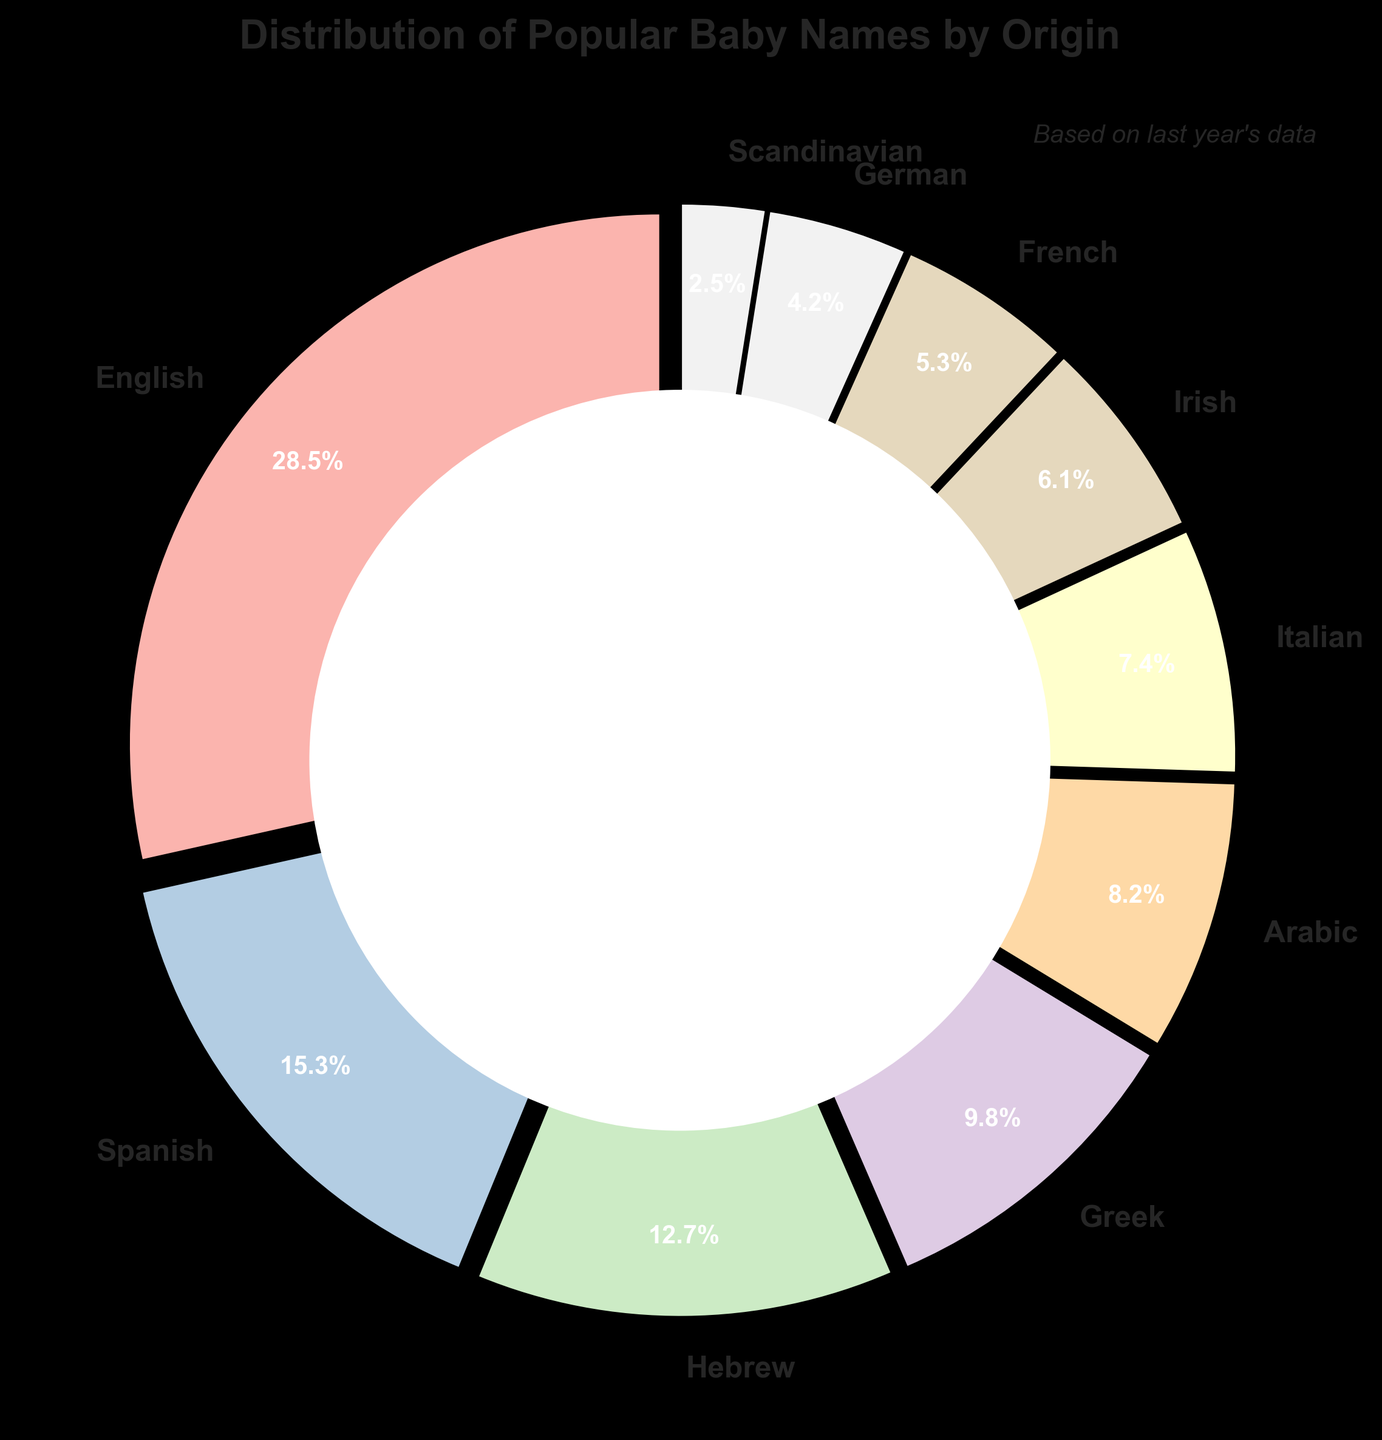Which origin has the highest percentage? Look at the pie chart and identify the section with the largest label and percentage.
Answer: English Which origins have a combined percentage of more than 40%? Sum the percentages of the origins and compare to 40%. English (28.5%) + Spanish (15.3%) = 43.8%
Answer: English and Spanish Is the percentage of Hebrew names greater than that of Irish names? Compare the percentage of Hebrew (12.7%) to Irish (6.1%).
Answer: Yes What is the difference in percentage points between English and Arabic origins? Subtract the percentage of Arabic (8.2%) from English (28.5%). 28.5 - 8.2 = 20.3
Answer: 20.3 Rank the origins from highest to lowest percentage. Sort the origins based on their percentages from the pie chart values.
Answer: English, Spanish, Hebrew, Greek, Arabic, Italian, Irish, French, German, Scandinavian Do Greek names represent more than 10% of the popular baby names? Look at the percentage value for Greek, which is 9.8%.
Answer: No Which three origins have the smallest percentages? Identify and list the three lowest percentages from the pie chart. Scandinavian (2.5%), German (4.2%), French (5.3%)
Answer: Scandinavian, German, French How much greater is the percentage of Italian names compared to German names? Subtract the percentage of German (4.2%) from Italian (7.4%). 7.4 - 4.2 = 3.2
Answer: 3.2 What is the median percentage value of the origins? List the percentages in order and identify the middle value. Ordered: 2.5, 4.2, 5.3, 6.1, 7.4, 8.2, 9.8, 12.7, 15.3, 28.5. Middle values: 7.4, 8.2. (7.4 + 8.2) / 2 = 7.8
Answer: 7.8 